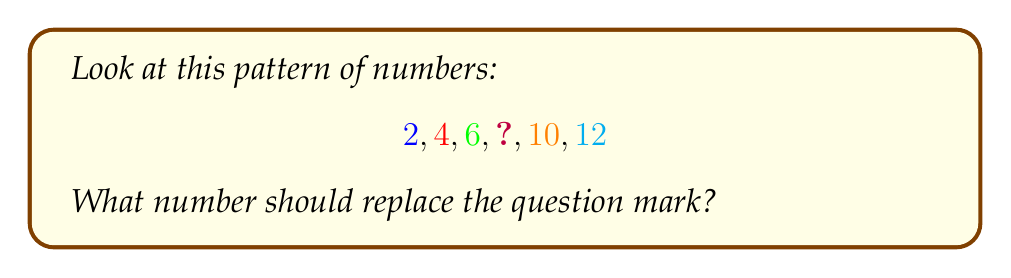Can you solve this math problem? Let's solve this step-by-step:

1) First, we need to identify the pattern in the sequence.

2) Let's look at how each number changes:
   - From 2 to 4: $4 - 2 = 2$
   - From 4 to 6: $6 - 4 = 2$
   - From 6 to the missing number: unknown
   - From the missing number to 10: unknown
   - From 10 to 12: $12 - 10 = 2$

3) We can see that each number increases by 2.

4) This is called an arithmetic sequence, where the difference between each consecutive term is constant.

5) In this case, the common difference is 2.

6) So, to find the missing number, we add 2 to the previous number:
   $6 + 2 = 8$

7) We can verify this by checking if 8 fits the pattern:
   $8 + 2 = 10$, which is the next number in the sequence.

Therefore, the missing number in the pattern is 8.
Answer: 8 